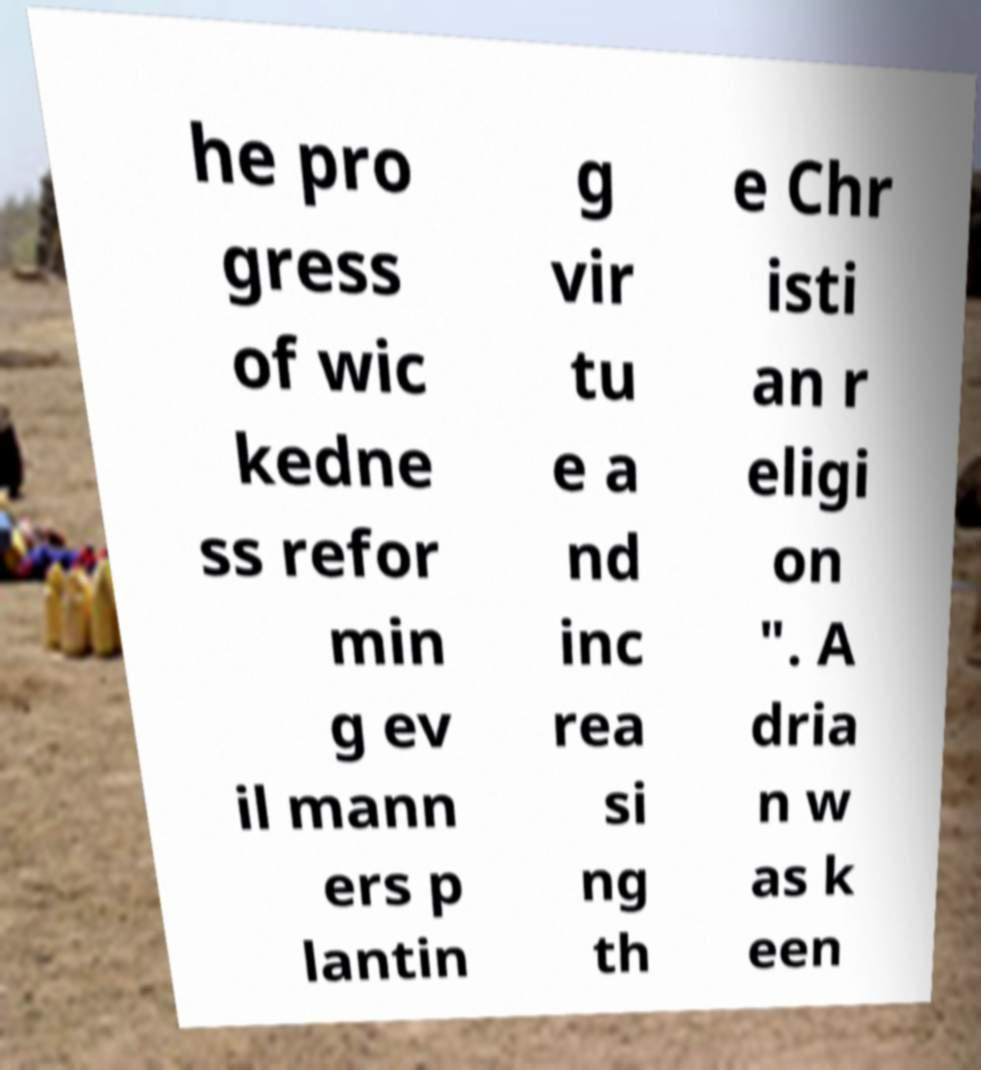There's text embedded in this image that I need extracted. Can you transcribe it verbatim? he pro gress of wic kedne ss refor min g ev il mann ers p lantin g vir tu e a nd inc rea si ng th e Chr isti an r eligi on ". A dria n w as k een 